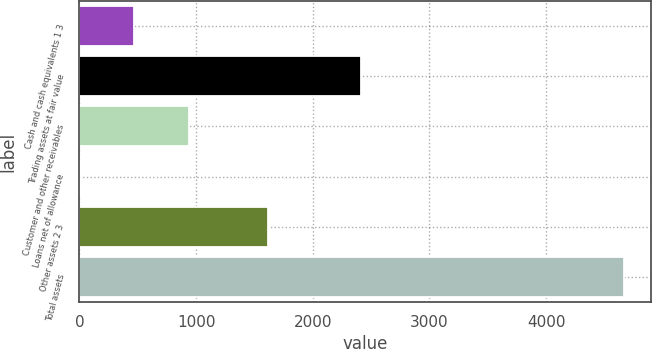Convert chart. <chart><loc_0><loc_0><loc_500><loc_500><bar_chart><fcel>Cash and cash equivalents 1 3<fcel>Trading assets at fair value<fcel>Customer and other receivables<fcel>Loans net of allowance<fcel>Other assets 2 3<fcel>Total assets<nl><fcel>471<fcel>2410<fcel>937<fcel>5<fcel>1614<fcel>4665<nl></chart> 